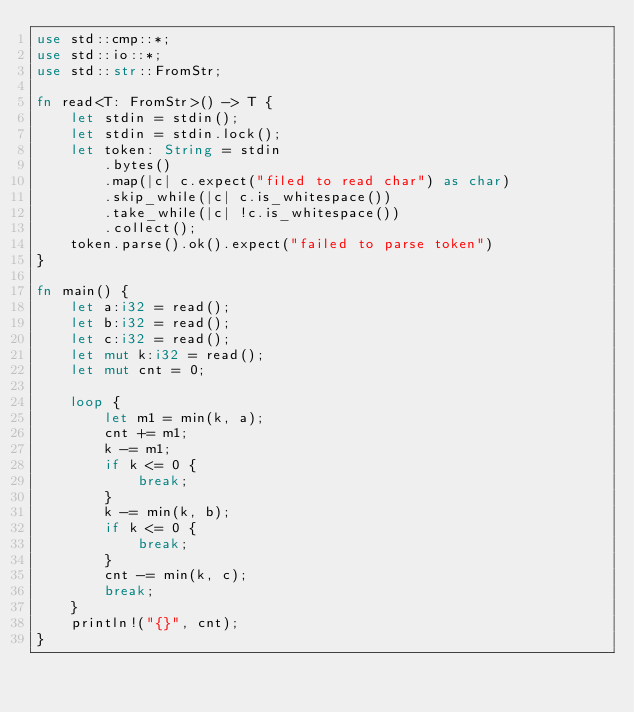<code> <loc_0><loc_0><loc_500><loc_500><_Rust_>use std::cmp::*;
use std::io::*;
use std::str::FromStr;

fn read<T: FromStr>() -> T {
    let stdin = stdin();
    let stdin = stdin.lock();
    let token: String = stdin
        .bytes()
        .map(|c| c.expect("filed to read char") as char)
        .skip_while(|c| c.is_whitespace())
        .take_while(|c| !c.is_whitespace())
        .collect();
    token.parse().ok().expect("failed to parse token")
}

fn main() {
    let a:i32 = read();
    let b:i32 = read();
    let c:i32 = read();
    let mut k:i32 = read();
    let mut cnt = 0;

    loop {
        let m1 = min(k, a);
        cnt += m1;
        k -= m1;
        if k <= 0 {
            break;
        }
        k -= min(k, b);
        if k <= 0 {
            break;
        }
        cnt -= min(k, c);
        break;
    }
    println!("{}", cnt);
}
</code> 